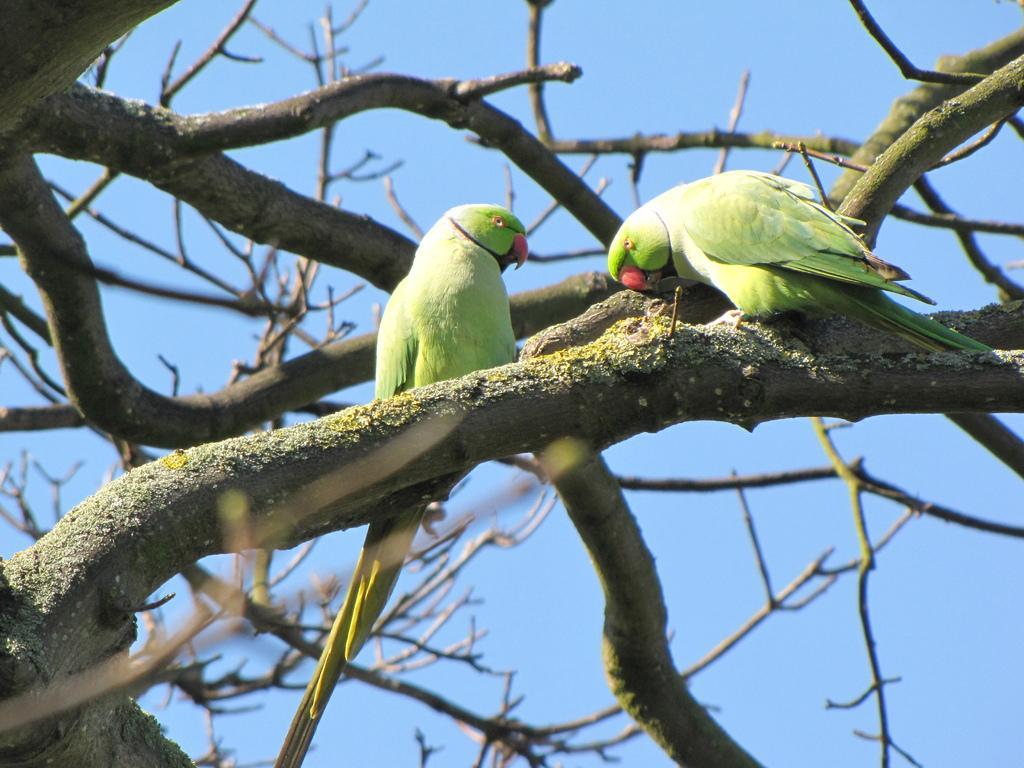How would you summarize this image in a sentence or two? In the background we can see the sky. In this picture we can see the branches and parrots. 